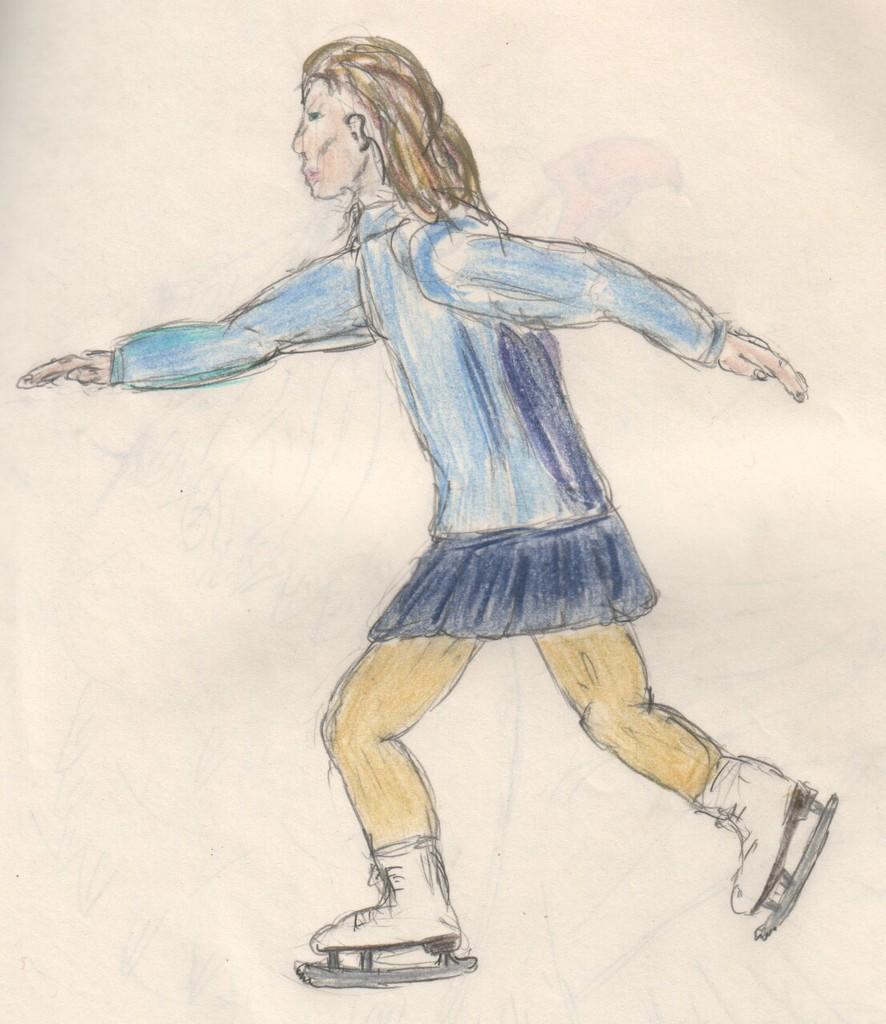Describe this image in one or two sentences. In this picture, we see the drawing of the girl who is skating and it is colored in blue and yellow color. In the background, it is white in color. This might be drawn on the paper. 